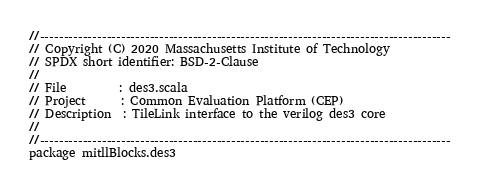<code> <loc_0><loc_0><loc_500><loc_500><_Scala_>//--------------------------------------------------------------------------------------
// Copyright (C) 2020 Massachusetts Institute of Technology
// SPDX short identifier: BSD-2-Clause
//
// File         : des3.scala
// Project      : Common Evaluation Platform (CEP)
// Description  : TileLink interface to the verilog des3 core
//
//--------------------------------------------------------------------------------------
package mitllBlocks.des3
</code> 